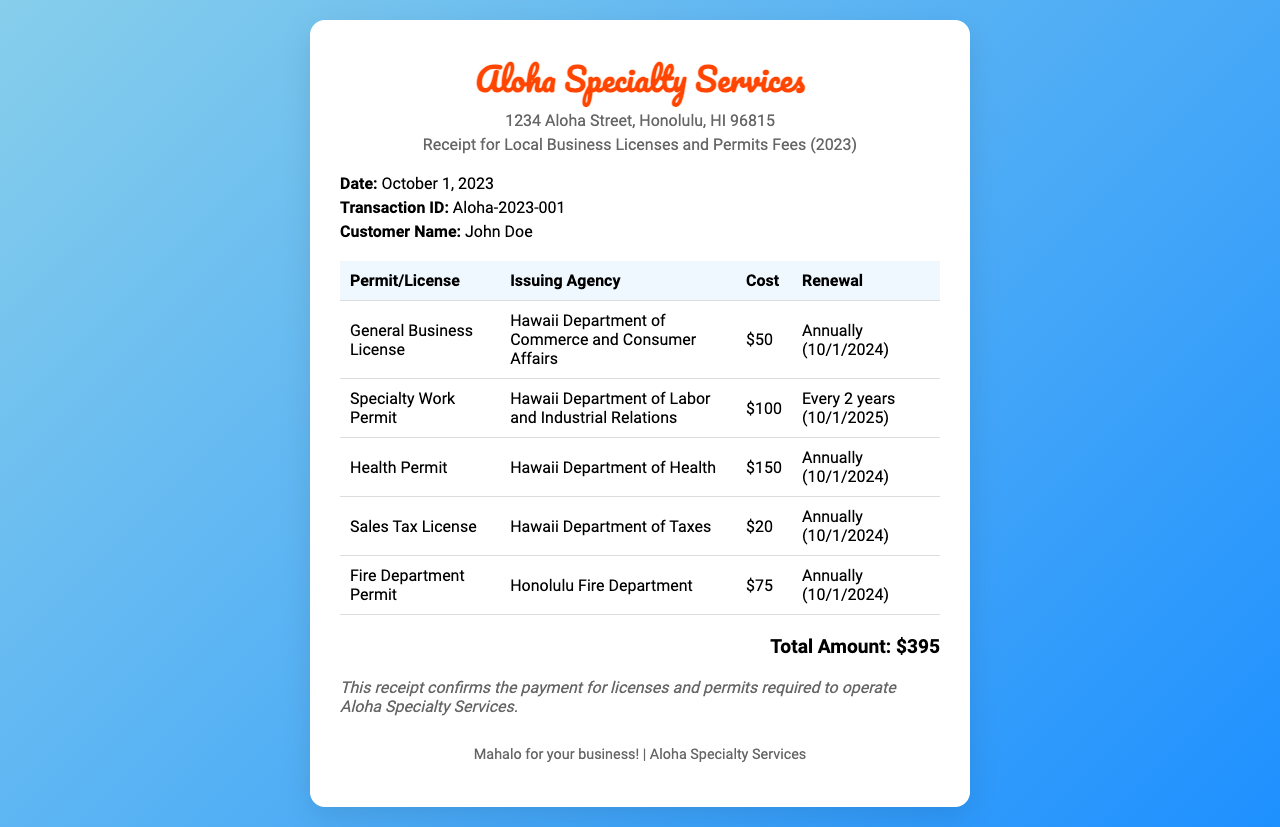What is the issuing agency for the General Business License? The issuing agency for the General Business License is mentioned in the document as the Hawaii Department of Commerce and Consumer Affairs.
Answer: Hawaii Department of Commerce and Consumer Affairs What is the total amount of fees paid? The document lists the total amount of fees at the bottom, which is the sum of all permit costs.
Answer: $395 When is the renewal date for the Health Permit? The renewal date for the Health Permit can be found in the document, noted specifically for annual renewals.
Answer: 10/1/2024 How much does the Specialty Work Permit cost? The cost of the Specialty Work Permit is clearly stated in the document as part of the permits table.
Answer: $100 How often must the Sales Tax License be renewed? The document provides information on the renewal frequency for the Sales Tax License.
Answer: Annually What is the address of Aloha Specialty Services? The address for Aloha Specialty Services is mentioned near the top of the document.
Answer: 1234 Aloha Street, Honolulu, HI 96815 Which document is being referred to? The document title provides the specific type of receipt being issued.
Answer: Receipt for Local Business Licenses and Permits Fees (2023) Who is the customer named in the receipt? The customer's name is specified in the details section of the document.
Answer: John Doe What is the cost of the Fire Department Permit? The cost for the Fire Department Permit is indicated in the list of permits.
Answer: $75 